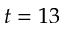Convert formula to latex. <formula><loc_0><loc_0><loc_500><loc_500>t = 1 3</formula> 